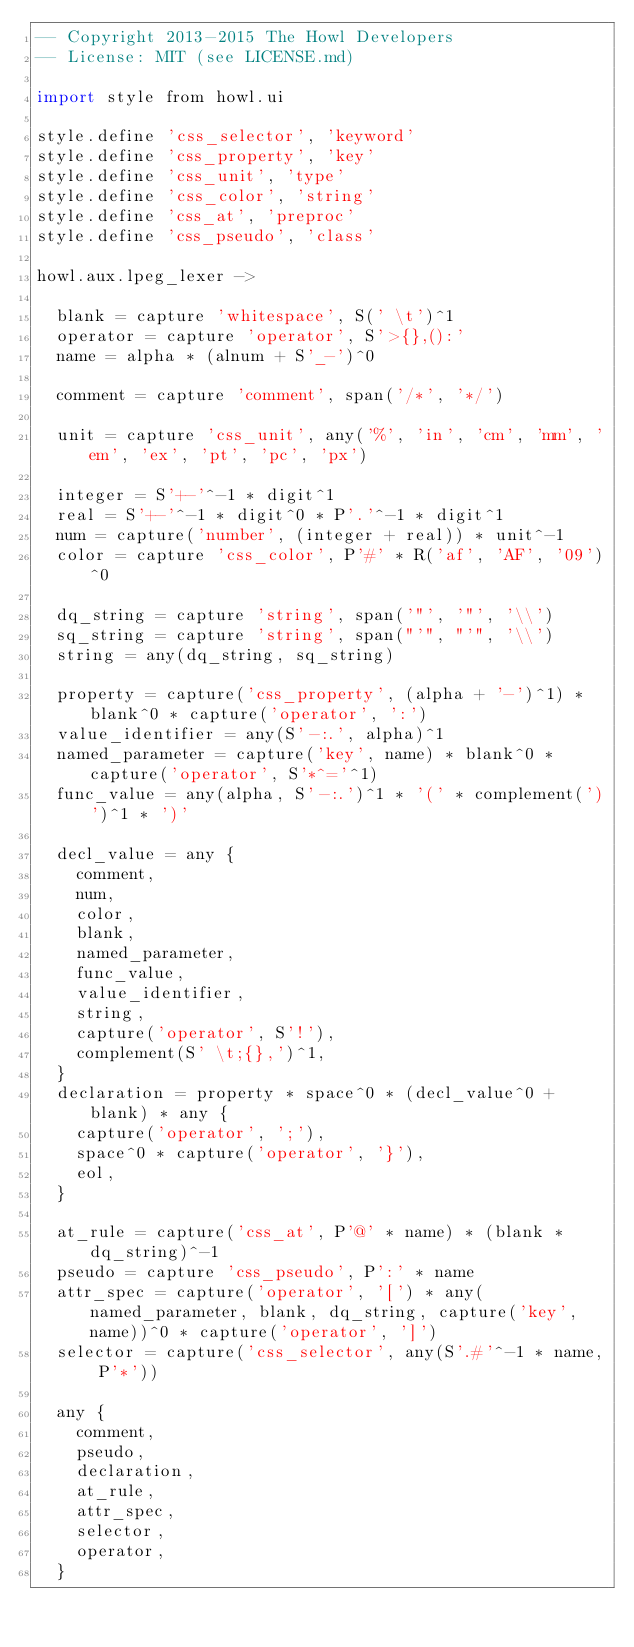<code> <loc_0><loc_0><loc_500><loc_500><_MoonScript_>-- Copyright 2013-2015 The Howl Developers
-- License: MIT (see LICENSE.md)

import style from howl.ui

style.define 'css_selector', 'keyword'
style.define 'css_property', 'key'
style.define 'css_unit', 'type'
style.define 'css_color', 'string'
style.define 'css_at', 'preproc'
style.define 'css_pseudo', 'class'

howl.aux.lpeg_lexer ->

  blank = capture 'whitespace', S(' \t')^1
  operator = capture 'operator', S'>{},():'
  name = alpha * (alnum + S'_-')^0

  comment = capture 'comment', span('/*', '*/')

  unit = capture 'css_unit', any('%', 'in', 'cm', 'mm', 'em', 'ex', 'pt', 'pc', 'px')

  integer = S'+-'^-1 * digit^1
  real = S'+-'^-1 * digit^0 * P'.'^-1 * digit^1
  num = capture('number', (integer + real)) * unit^-1
  color = capture 'css_color', P'#' * R('af', 'AF', '09')^0

  dq_string = capture 'string', span('"', '"', '\\')
  sq_string = capture 'string', span("'", "'", '\\')
  string = any(dq_string, sq_string)

  property = capture('css_property', (alpha + '-')^1) * blank^0 * capture('operator', ':')
  value_identifier = any(S'-:.', alpha)^1
  named_parameter = capture('key', name) * blank^0 * capture('operator', S'*^='^1)
  func_value = any(alpha, S'-:.')^1 * '(' * complement(')')^1 * ')'

  decl_value = any {
    comment,
    num,
    color,
    blank,
    named_parameter,
    func_value,
    value_identifier,
    string,
    capture('operator', S'!'),
    complement(S' \t;{},')^1,
  }
  declaration = property * space^0 * (decl_value^0 + blank) * any {
    capture('operator', ';'),
    space^0 * capture('operator', '}'),
    eol,
  }

  at_rule = capture('css_at', P'@' * name) * (blank * dq_string)^-1
  pseudo = capture 'css_pseudo', P':' * name
  attr_spec = capture('operator', '[') * any(named_parameter, blank, dq_string, capture('key', name))^0 * capture('operator', ']')
  selector = capture('css_selector', any(S'.#'^-1 * name, P'*'))

  any {
    comment,
    pseudo,
    declaration,
    at_rule,
    attr_spec,
    selector,
    operator,
  }
</code> 